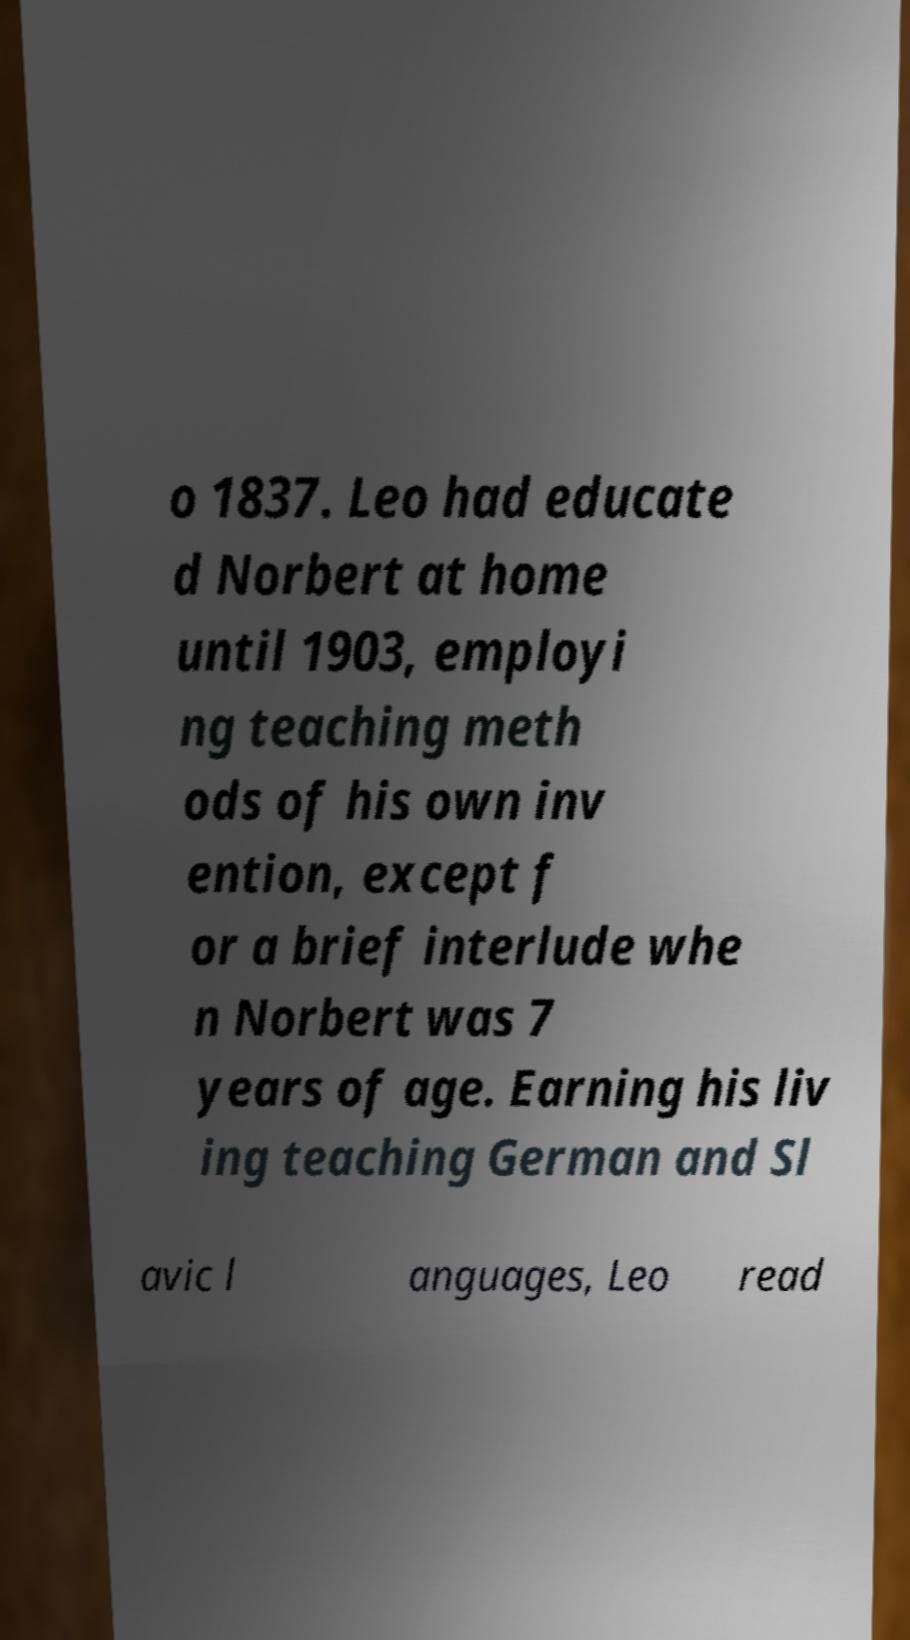Please identify and transcribe the text found in this image. o 1837. Leo had educate d Norbert at home until 1903, employi ng teaching meth ods of his own inv ention, except f or a brief interlude whe n Norbert was 7 years of age. Earning his liv ing teaching German and Sl avic l anguages, Leo read 